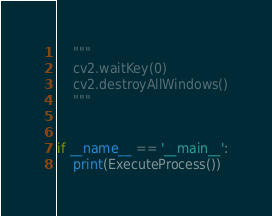Convert code to text. <code><loc_0><loc_0><loc_500><loc_500><_Python_>    """
    cv2.waitKey(0)
    cv2.destroyAllWindows()
    """


if __name__ == '__main__':
    print(ExecuteProcess())</code> 